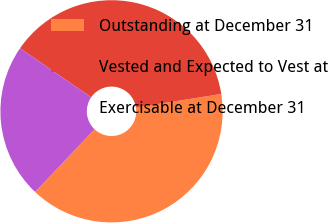Convert chart to OTSL. <chart><loc_0><loc_0><loc_500><loc_500><pie_chart><fcel>Outstanding at December 31<fcel>Vested and Expected to Vest at<fcel>Exercisable at December 31<nl><fcel>39.56%<fcel>37.9%<fcel>22.54%<nl></chart> 